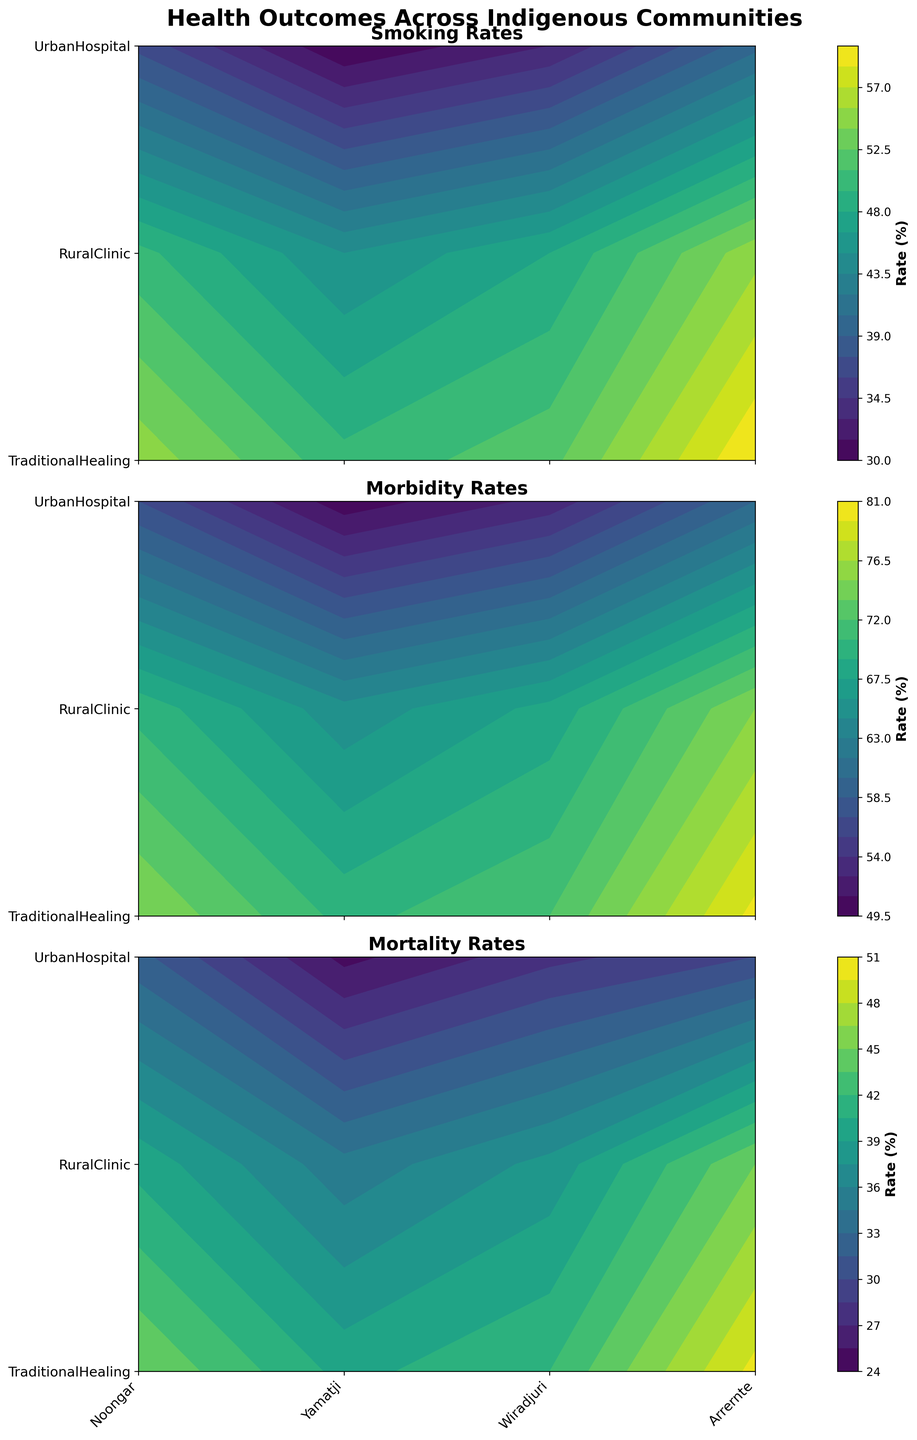What's the title of the figure? The title of the figure is at the top of the plot and is usually displayed prominently in larger and bold font.
Answer: Health Outcomes Across Indigenous Communities How many indigenous communities are shown in the figure? The indigenous communities are labeled along the x-axis of the subplots. By counting the unique labels, we find the number of communities.
Answer: 4 Which indigenous community has the highest smoking rates under Rural Clinic intervention? By examining the subplot for Smoking Rates and looking at the color intensity corresponding to the Rural Clinic intervention, we can identify the community with the highest rate.
Answer: Yamatji What intervention has the lowest mortality rate for the Noongar community? Look at the Mortality Rates subplot, find the Noongar community along the x-axis and compare the color intensities across the interventions on the y-axis. The one with the lightest color has the lowest rate.
Answer: Urban Hospital Compare the morbidity rates between Traditional Healing and Urban Hospital interventions for the Arrernte community. Which is higher? By comparing the color intensity of the Arrernte community in the Morbidity Rates subplot, we see the traditional healing intervention has darker shades than urban hospital, indicating a higher rate.
Answer: Traditional Healing Which community has the highest difference in smoking rates between Urban Hospital and Traditional Healing interventions? Calculate the differences in contour color intensities for each community between Urban Hospital and Traditional Healing in the Smoking Rates subplot. The community with the largest color disparity has the highest difference.
Answer: Yamatji What is the average mortality rate for the Wiradjuri community across all interventions? Find the mortality rates for Wiradjuri under each intervention, sum them up and divide by the number of interventions (3). Average = (38 + 42 + 28) / 3.
Answer: 36% In which community and intervention is the morbidity rate exactly 75%? Look for the contour line labeled 75% in the Morbidity Rates subplot and identify which community and intervention it crosses.
Answer: Yamatji, Rural Clinic Among the Arrernte community, how does the smoking rate under Urban Hospital compare to Rural Clinic? By comparing the color intensities in the Smoking Rates subplot for Arrernte under Urban Hospital and Rural Clinic, the one with lighter color has a lower rate.
Answer: Urban Hospital is lower What is the general trend in mortality rates from Traditional Healing to Urban Hospital across all communities? By observing the progression of color intensities from Traditional Healing to Urban Hospital in the Mortality Rates subplot, a general trend can be determined.
Answer: Decreasing 